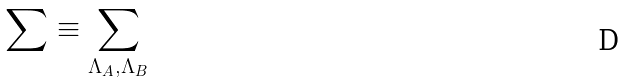Convert formula to latex. <formula><loc_0><loc_0><loc_500><loc_500>\sum \equiv \sum _ { \Lambda _ { A } , \Lambda _ { B } }</formula> 